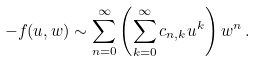<formula> <loc_0><loc_0><loc_500><loc_500>- f ( u , w ) \sim \sum _ { n = 0 } ^ { \infty } \left ( \sum _ { k = 0 } ^ { \infty } c _ { n , k } u ^ { k } \right ) w ^ { n } \, .</formula> 